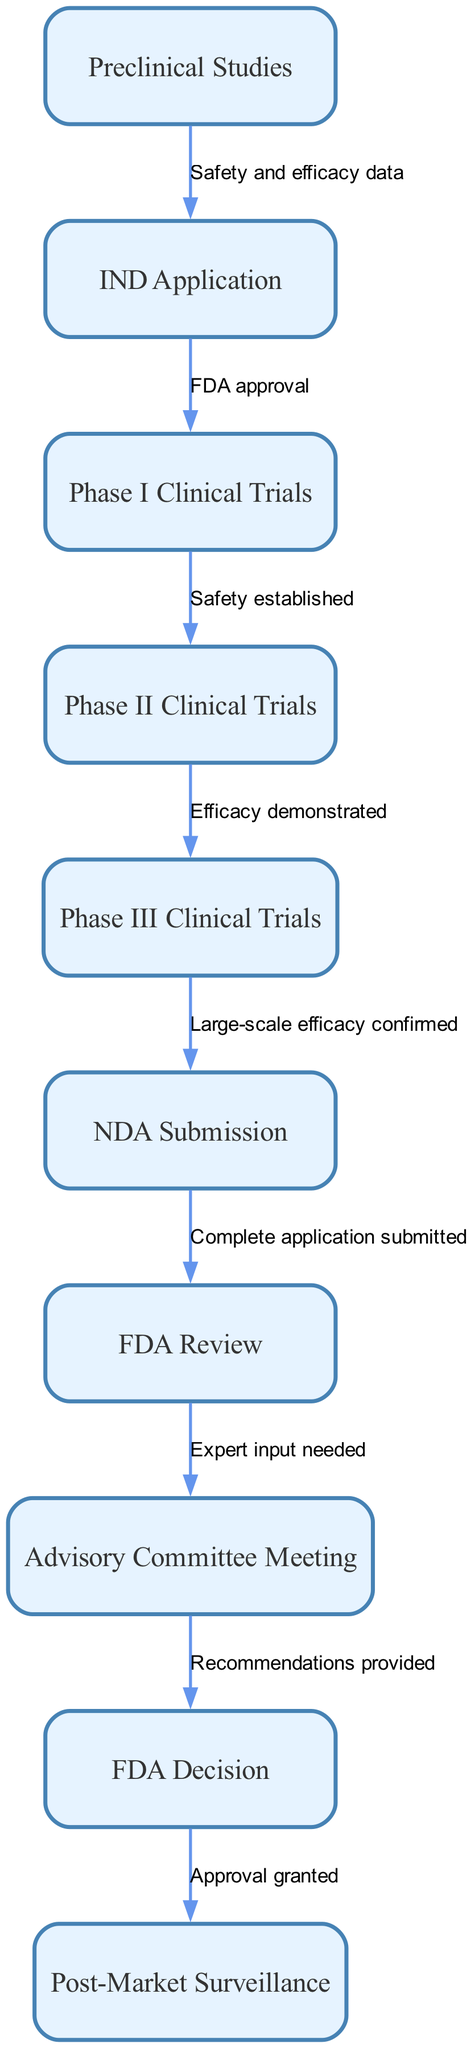What is the first step in the drug approval process? The first step identified in the diagram is "Preclinical Studies." It is the starting point from where the entire flowchart initiates, leading to the next phase.
Answer: Preclinical Studies How many nodes are present in the diagram? The diagram lists a total of 10 distinct nodes representing different stages of the drug approval process. Counting each node, we find ten unique steps outlined.
Answer: 10 What do “Phase II Clinical Trials” lead to? According to the flowchart, "Phase II Clinical Trials" lead to "Phase III Clinical Trials." This indicates that once Phase II trials are completed, the process continues to the next phase.
Answer: Phase III Clinical Trials What is required before submitting the IND Application? The diagram shows that "Safety and efficacy data" must be collected from "Preclinical Studies" before the IND Application can be submitted. This is a prerequisite for proceeding.
Answer: Safety and efficacy data What does the FDA review follow after? The "FDA Review" follows after the "NDA Submission." The sequence in the diagram illustrates that the review process is contingent upon a complete application being submitted.
Answer: NDA Submission How many edges connect the nodes in the flowchart? There are 9 edges connecting the 10 nodes in the flowchart, indicating the relationships and flow between the various stages of the approval process.
Answer: 9 What type of input is needed after the FDA Review? Following the "FDA Review," the diagram indicates that "Expert input needed" is required in the form of an "Advisory Committee Meeting." This step emphasizes the importance of external insights.
Answer: Expert input needed What happens after the FDA Decision? The flowchart indicates that after the "FDA Decision" is made, "Post-Market Surveillance" occurs. This shows that monitoring continues even after a drug is approved.
Answer: Post-Market Surveillance What is the main focus of “Phase I Clinical Trials”? The main focus of "Phase I Clinical Trials" is to establish safety, as indicated by the flow from this node to the following phases in the diagram. This suggests that safety is the primary concern at this stage.
Answer: Safety established 